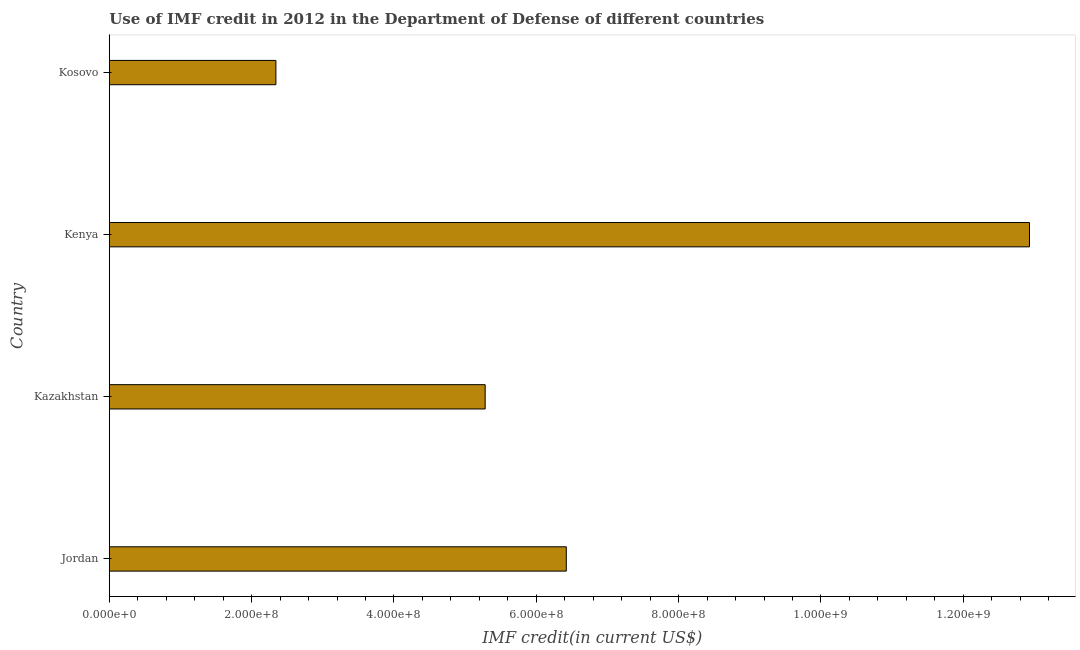Does the graph contain any zero values?
Make the answer very short. No. Does the graph contain grids?
Offer a terse response. No. What is the title of the graph?
Keep it short and to the point. Use of IMF credit in 2012 in the Department of Defense of different countries. What is the label or title of the X-axis?
Your answer should be very brief. IMF credit(in current US$). What is the use of imf credit in dod in Kosovo?
Your response must be concise. 2.34e+08. Across all countries, what is the maximum use of imf credit in dod?
Offer a terse response. 1.29e+09. Across all countries, what is the minimum use of imf credit in dod?
Offer a very short reply. 2.34e+08. In which country was the use of imf credit in dod maximum?
Offer a terse response. Kenya. In which country was the use of imf credit in dod minimum?
Give a very brief answer. Kosovo. What is the sum of the use of imf credit in dod?
Provide a succinct answer. 2.70e+09. What is the difference between the use of imf credit in dod in Jordan and Kosovo?
Offer a terse response. 4.08e+08. What is the average use of imf credit in dod per country?
Ensure brevity in your answer.  6.74e+08. What is the median use of imf credit in dod?
Provide a succinct answer. 5.85e+08. What is the ratio of the use of imf credit in dod in Kazakhstan to that in Kosovo?
Ensure brevity in your answer.  2.26. Is the use of imf credit in dod in Kenya less than that in Kosovo?
Keep it short and to the point. No. Is the difference between the use of imf credit in dod in Jordan and Kazakhstan greater than the difference between any two countries?
Your answer should be compact. No. What is the difference between the highest and the second highest use of imf credit in dod?
Make the answer very short. 6.51e+08. What is the difference between the highest and the lowest use of imf credit in dod?
Provide a succinct answer. 1.06e+09. What is the IMF credit(in current US$) in Jordan?
Offer a very short reply. 6.42e+08. What is the IMF credit(in current US$) of Kazakhstan?
Provide a short and direct response. 5.28e+08. What is the IMF credit(in current US$) of Kenya?
Keep it short and to the point. 1.29e+09. What is the IMF credit(in current US$) in Kosovo?
Make the answer very short. 2.34e+08. What is the difference between the IMF credit(in current US$) in Jordan and Kazakhstan?
Ensure brevity in your answer.  1.14e+08. What is the difference between the IMF credit(in current US$) in Jordan and Kenya?
Offer a terse response. -6.51e+08. What is the difference between the IMF credit(in current US$) in Jordan and Kosovo?
Provide a succinct answer. 4.08e+08. What is the difference between the IMF credit(in current US$) in Kazakhstan and Kenya?
Provide a short and direct response. -7.65e+08. What is the difference between the IMF credit(in current US$) in Kazakhstan and Kosovo?
Offer a very short reply. 2.94e+08. What is the difference between the IMF credit(in current US$) in Kenya and Kosovo?
Your answer should be very brief. 1.06e+09. What is the ratio of the IMF credit(in current US$) in Jordan to that in Kazakhstan?
Offer a very short reply. 1.22. What is the ratio of the IMF credit(in current US$) in Jordan to that in Kenya?
Your answer should be compact. 0.5. What is the ratio of the IMF credit(in current US$) in Jordan to that in Kosovo?
Provide a short and direct response. 2.74. What is the ratio of the IMF credit(in current US$) in Kazakhstan to that in Kenya?
Your answer should be compact. 0.41. What is the ratio of the IMF credit(in current US$) in Kazakhstan to that in Kosovo?
Provide a short and direct response. 2.26. What is the ratio of the IMF credit(in current US$) in Kenya to that in Kosovo?
Your answer should be compact. 5.52. 